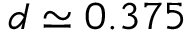Convert formula to latex. <formula><loc_0><loc_0><loc_500><loc_500>d \simeq 0 . 3 7 5</formula> 